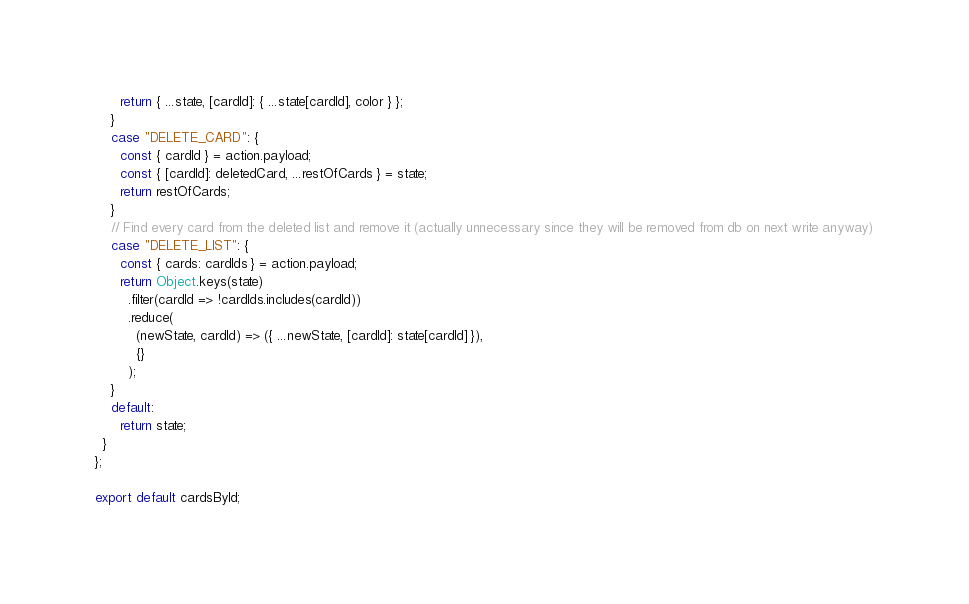<code> <loc_0><loc_0><loc_500><loc_500><_JavaScript_>      return { ...state, [cardId]: { ...state[cardId], color } };
    }
    case "DELETE_CARD": {
      const { cardId } = action.payload;
      const { [cardId]: deletedCard, ...restOfCards } = state;
      return restOfCards;
    }
    // Find every card from the deleted list and remove it (actually unnecessary since they will be removed from db on next write anyway)
    case "DELETE_LIST": {
      const { cards: cardIds } = action.payload;
      return Object.keys(state)
        .filter(cardId => !cardIds.includes(cardId))
        .reduce(
          (newState, cardId) => ({ ...newState, [cardId]: state[cardId] }),
          {}
        );
    }
    default:
      return state;
  }
};

export default cardsById;
</code> 